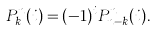Convert formula to latex. <formula><loc_0><loc_0><loc_500><loc_500>P _ { k } ^ { n } ( i ) = ( - 1 ) ^ { i } P _ { n - k } ^ { n } ( i ) .</formula> 